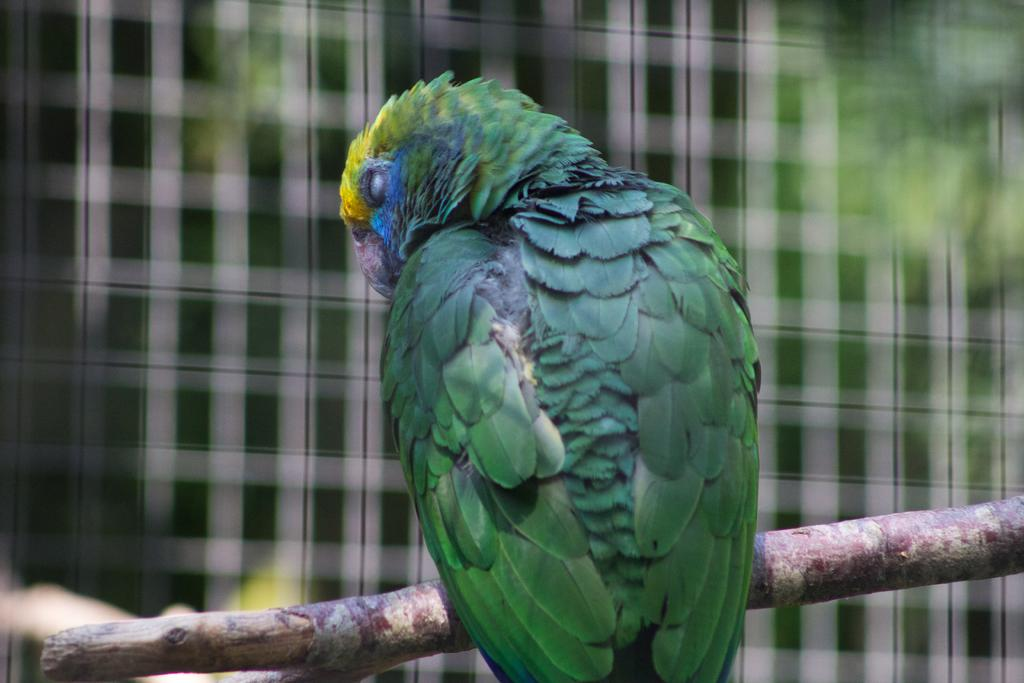What type of animal is present in the image? There is a bird in the image. Where is the bird located in the image? The bird is on a stem. What type of hydrant can be seen in the image? There is no hydrant present in the image. Is the bird playing a drum in the image? There is no drum present in the image, and the bird is not shown playing any instrument. 